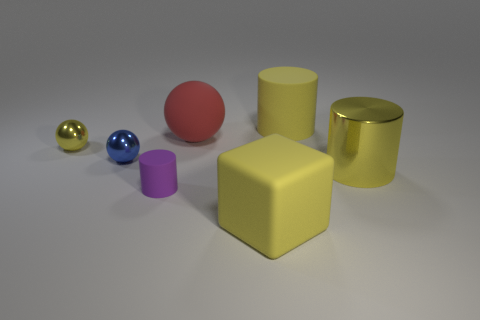Add 3 big red balls. How many objects exist? 10 Subtract all cubes. How many objects are left? 6 Subtract 0 gray balls. How many objects are left? 7 Subtract all brown metallic things. Subtract all tiny rubber cylinders. How many objects are left? 6 Add 6 large yellow metallic cylinders. How many large yellow metallic cylinders are left? 7 Add 6 blue matte objects. How many blue matte objects exist? 6 